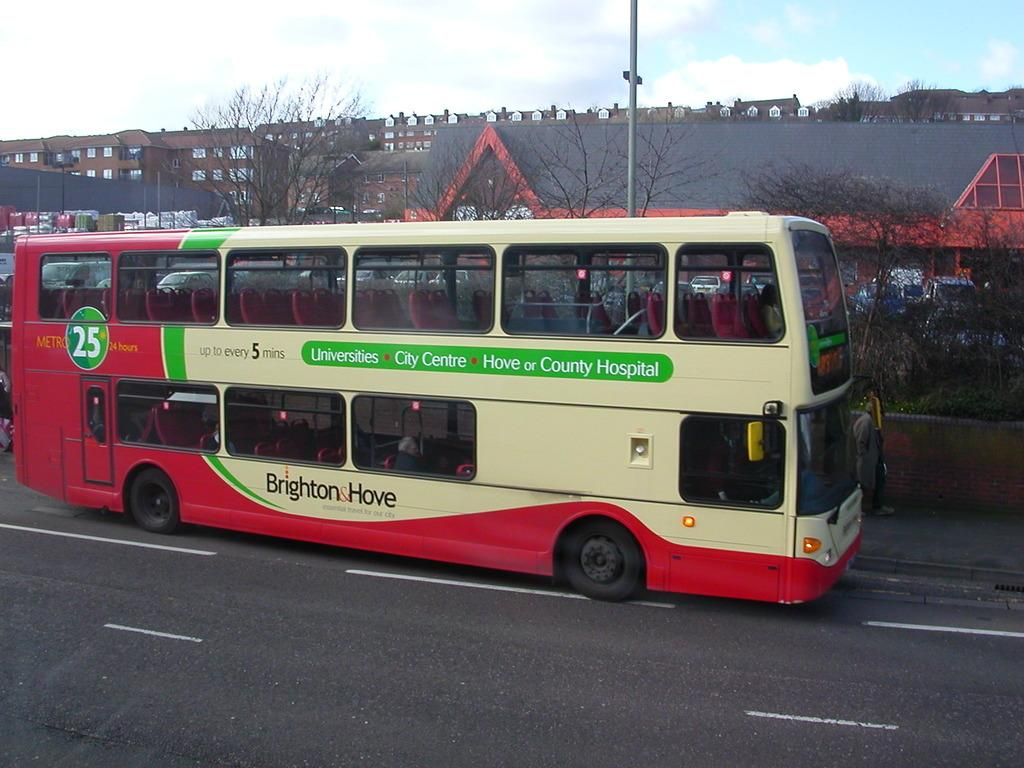<image>
Render a clear and concise summary of the photo. A double decker bus that says Universities City Centre Hove or County Hospital and Brighton Hove on the side of the bus. 